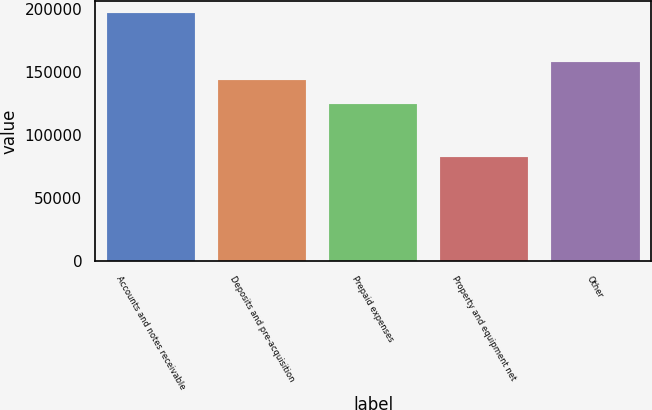<chart> <loc_0><loc_0><loc_500><loc_500><bar_chart><fcel>Accounts and notes receivable<fcel>Deposits and pre-acquisition<fcel>Prepaid expenses<fcel>Property and equipment net<fcel>Other<nl><fcel>196622<fcel>143502<fcel>124790<fcel>82419<fcel>157707<nl></chart> 